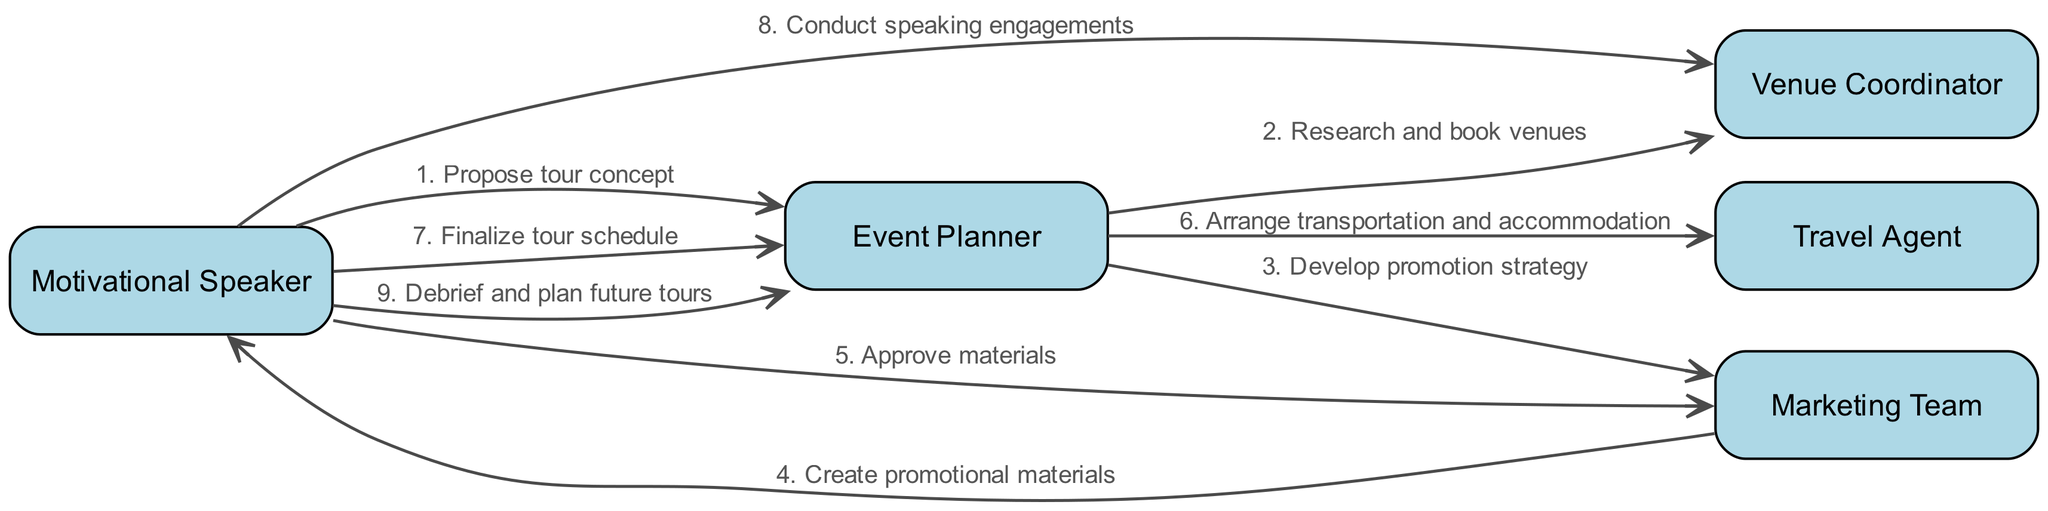What is the first action taken by the Motivational Speaker? The first action shown in the sequence is the Motivational Speaker proposing a tour concept to the Event Planner. This is clearly indicated as the first step in the workflow.
Answer: Propose tour concept How many actors are involved in the workflow? By looking at the diagram, we can see five different actors listed who play various roles in the planning and execution of the motivational speaking tour.
Answer: Five What does the Event Planner do after receiving the tour concept? The next action after receiving the proposal from the Motivational Speaker is that the Event Planner researches and books venues, as indicated in the sequence following the initial message.
Answer: Research and book venues Which team is responsible for creating promotional materials? The Marketing Team is tasked with creating promotional materials, as indicated in the sequence that follows the development of a promotion strategy by the Event Planner.
Answer: Marketing Team What is the final action taken by the Motivational Speaker in the sequence? The final action mentioned is that the Motivational Speaker conducts debriefing and plans for future tours, indicating a feedback session after the tour engagements.
Answer: Debrief and plan future tours What is the role of the Travel Agent in the workflow? The Travel Agent's role involves arranging transportation and accommodation, which is clearly outlined in the sequence following the actions of the Event Planner.
Answer: Arrange transportation and accommodation How many messages are exchanged between the Motivational Speaker and the Event Planner? By analyzing the sequence, we find that there are three separate messages exchanged between these two actors, indicative of their ongoing communication throughout the workflow.
Answer: Three In which step does the Motivational Speaker approve materials? The step where the Motivational Speaker approves materials occurs after the Marketing Team creates them, specifically positioned in the sequence right before the finalization of the tour schedule.
Answer: Approve materials What is the sequence number for "Conduct speaking engagements"? In the order of the sequence, the step "Conduct speaking engagements" is labeled as the eighth action, making it easy to identify within the entire flow of messages.
Answer: Eight 